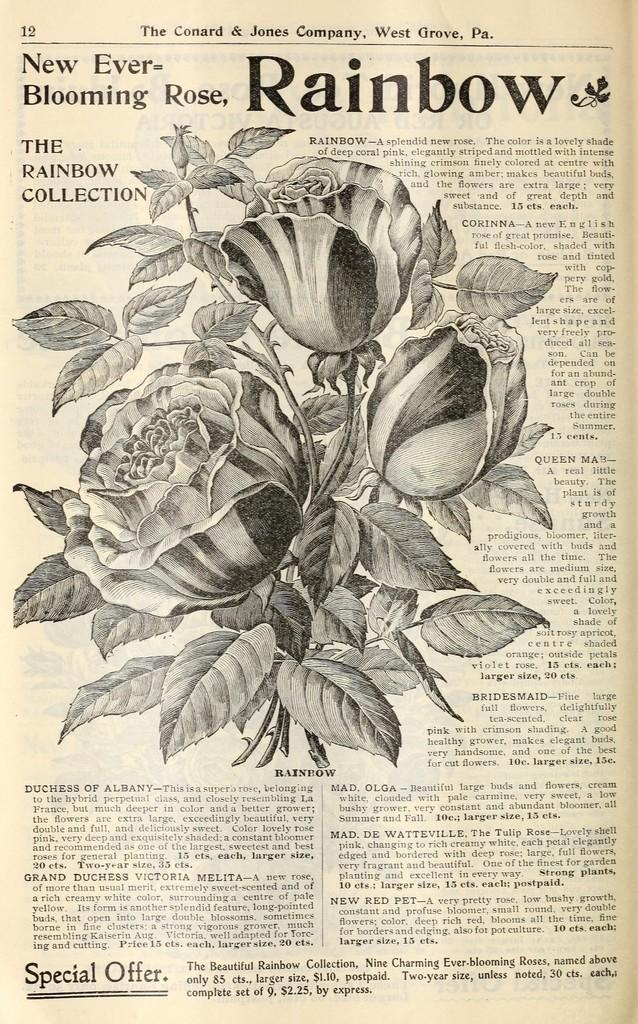What is the main subject of the image? The main subject of the image is a paper. What is depicted on the paper? The paper contains a picture of flowers and leaves. Is there any text on the paper? Yes, there is text written on the paper. How many ladybugs can be seen crawling on the fruit in the image? There are no ladybugs or fruit present in the image; it only features a paper with a picture of flowers and leaves and text. 